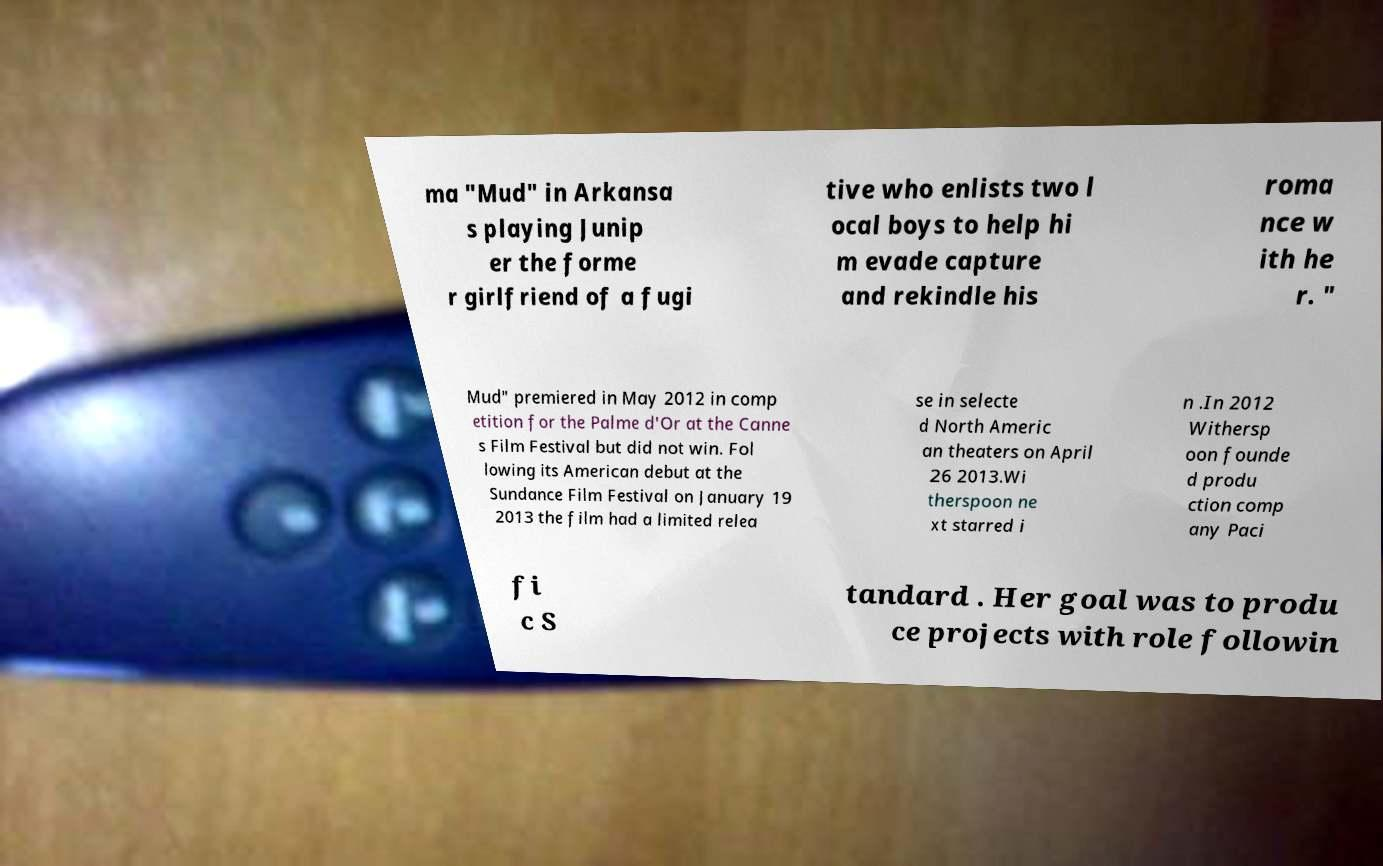What messages or text are displayed in this image? I need them in a readable, typed format. ma "Mud" in Arkansa s playing Junip er the forme r girlfriend of a fugi tive who enlists two l ocal boys to help hi m evade capture and rekindle his roma nce w ith he r. " Mud" premiered in May 2012 in comp etition for the Palme d'Or at the Canne s Film Festival but did not win. Fol lowing its American debut at the Sundance Film Festival on January 19 2013 the film had a limited relea se in selecte d North Americ an theaters on April 26 2013.Wi therspoon ne xt starred i n .In 2012 Withersp oon founde d produ ction comp any Paci fi c S tandard . Her goal was to produ ce projects with role followin 